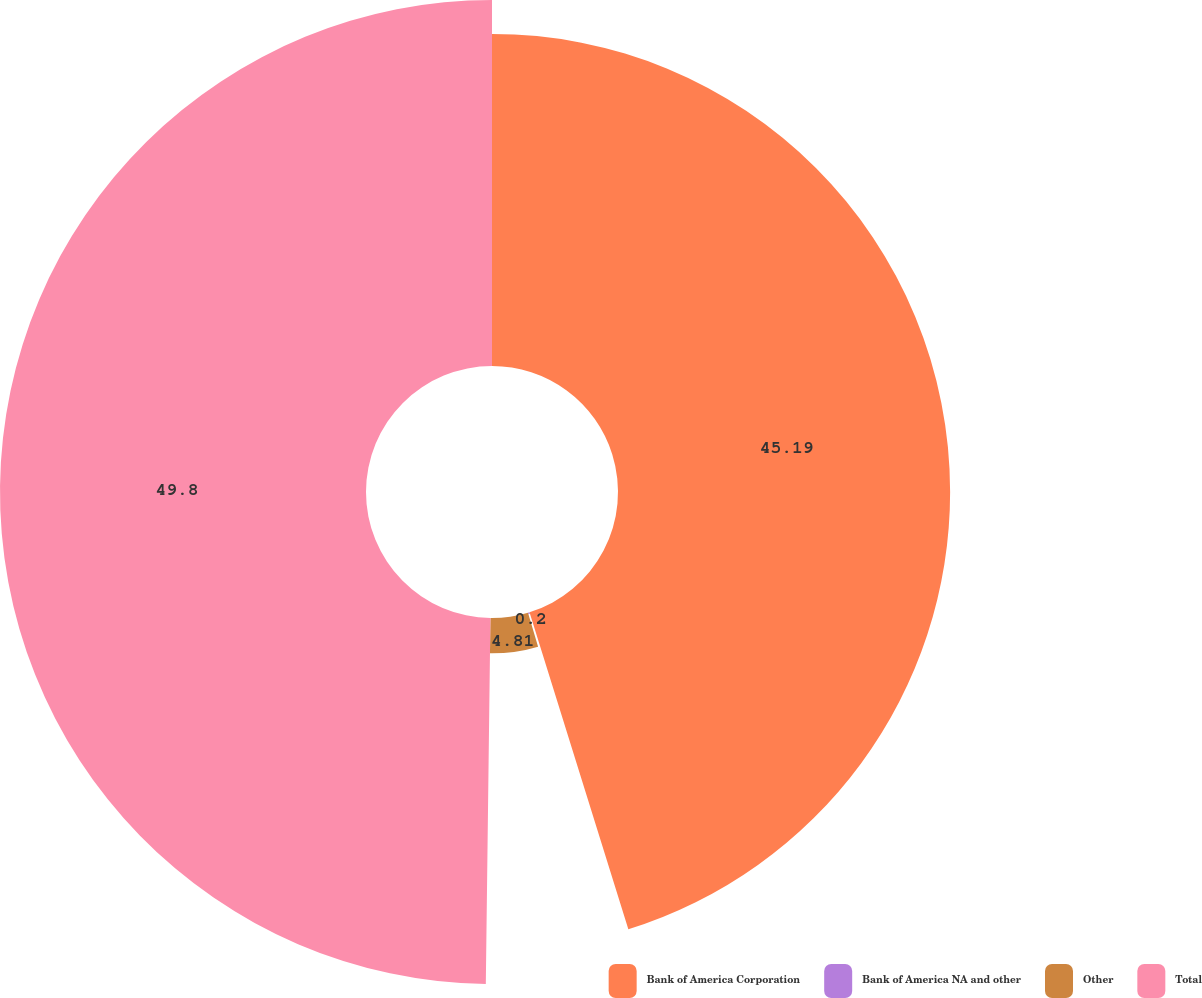Convert chart to OTSL. <chart><loc_0><loc_0><loc_500><loc_500><pie_chart><fcel>Bank of America Corporation<fcel>Bank of America NA and other<fcel>Other<fcel>Total<nl><fcel>45.19%<fcel>0.2%<fcel>4.81%<fcel>49.8%<nl></chart> 